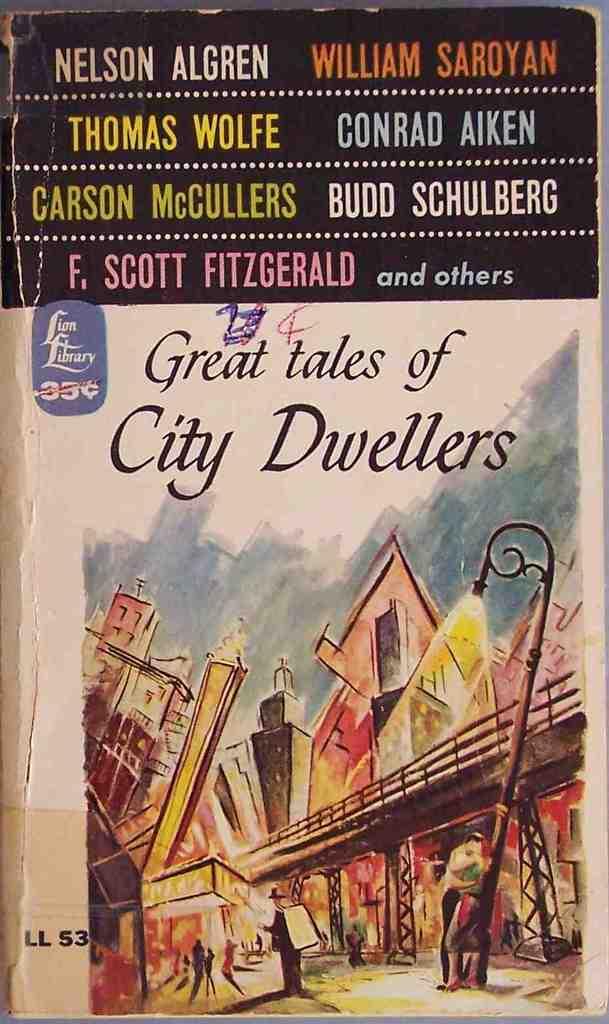What is the title of this book?
Offer a terse response. Great tales of city dwellers. 